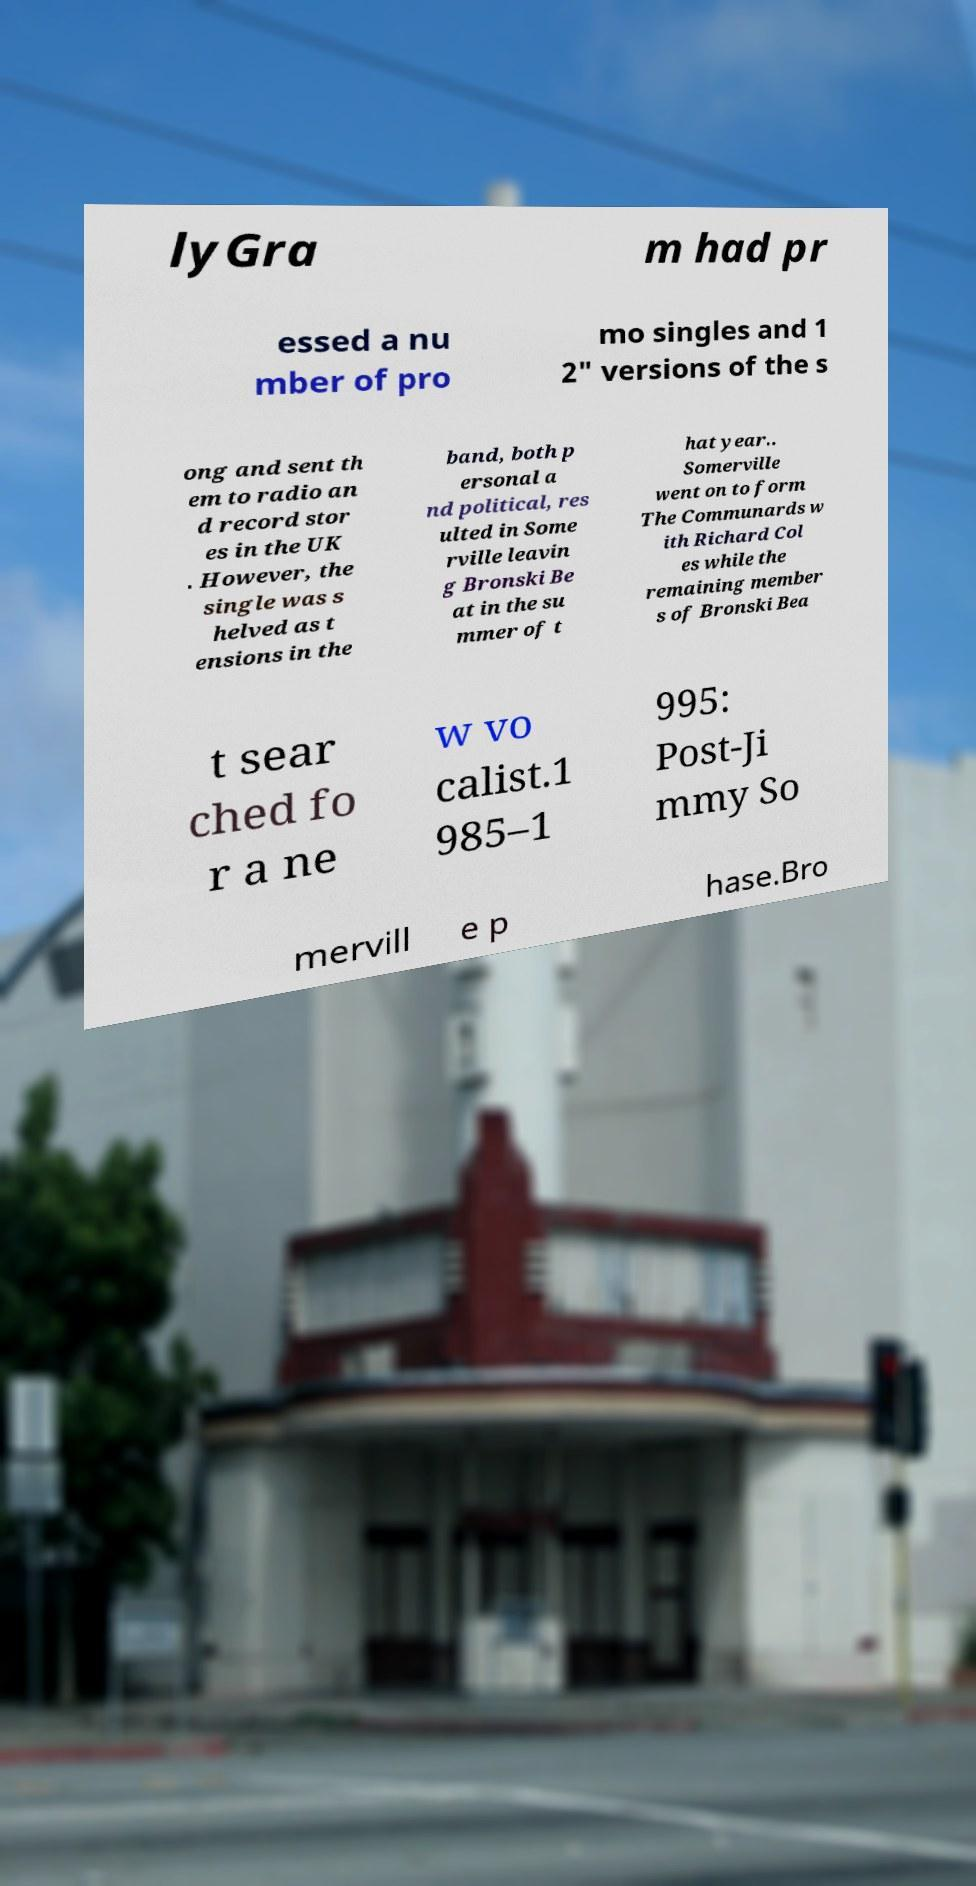Can you read and provide the text displayed in the image?This photo seems to have some interesting text. Can you extract and type it out for me? lyGra m had pr essed a nu mber of pro mo singles and 1 2" versions of the s ong and sent th em to radio an d record stor es in the UK . However, the single was s helved as t ensions in the band, both p ersonal a nd political, res ulted in Some rville leavin g Bronski Be at in the su mmer of t hat year.. Somerville went on to form The Communards w ith Richard Col es while the remaining member s of Bronski Bea t sear ched fo r a ne w vo calist.1 985–1 995: Post-Ji mmy So mervill e p hase.Bro 